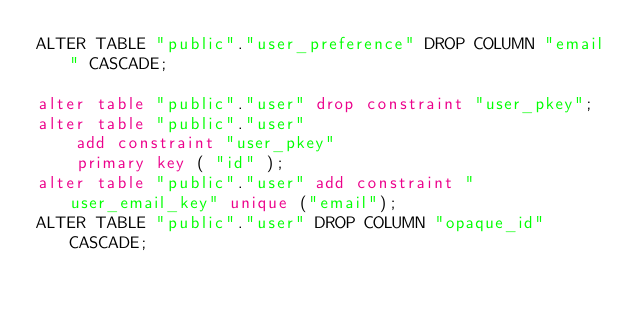Convert code to text. <code><loc_0><loc_0><loc_500><loc_500><_SQL_>ALTER TABLE "public"."user_preference" DROP COLUMN "email" CASCADE;

alter table "public"."user" drop constraint "user_pkey";
alter table "public"."user"
    add constraint "user_pkey"
    primary key ( "id" );
alter table "public"."user" add constraint "user_email_key" unique ("email");
ALTER TABLE "public"."user" DROP COLUMN "opaque_id" CASCADE;
</code> 